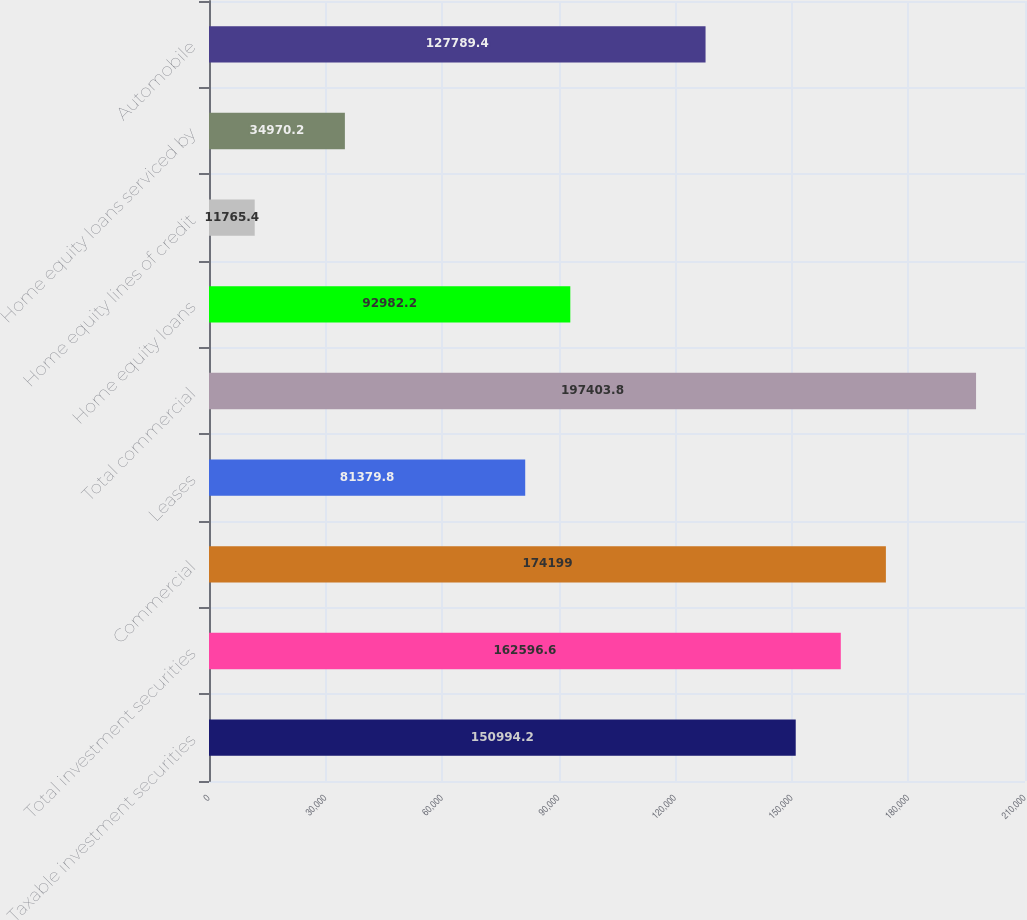Convert chart to OTSL. <chart><loc_0><loc_0><loc_500><loc_500><bar_chart><fcel>Taxable investment securities<fcel>Total investment securities<fcel>Commercial<fcel>Leases<fcel>Total commercial<fcel>Home equity loans<fcel>Home equity lines of credit<fcel>Home equity loans serviced by<fcel>Automobile<nl><fcel>150994<fcel>162597<fcel>174199<fcel>81379.8<fcel>197404<fcel>92982.2<fcel>11765.4<fcel>34970.2<fcel>127789<nl></chart> 